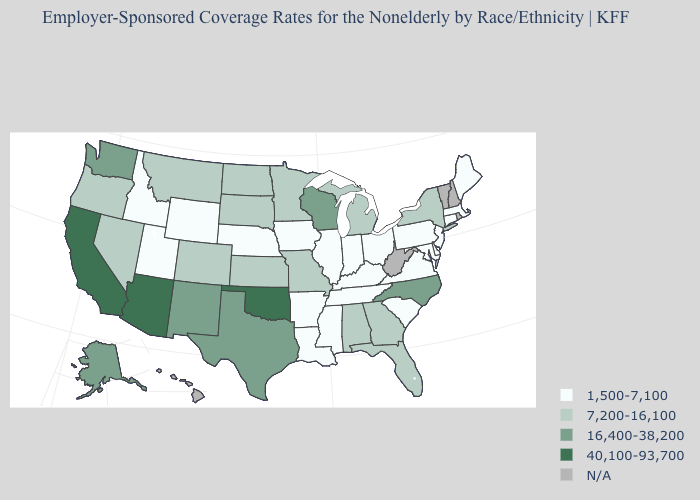Which states have the lowest value in the USA?
Write a very short answer. Arkansas, Connecticut, Delaware, Idaho, Illinois, Indiana, Iowa, Kentucky, Louisiana, Maine, Maryland, Massachusetts, Mississippi, Nebraska, New Jersey, Ohio, Pennsylvania, South Carolina, Tennessee, Utah, Virginia, Wyoming. What is the value of Oregon?
Short answer required. 7,200-16,100. What is the value of Iowa?
Short answer required. 1,500-7,100. Which states have the lowest value in the USA?
Be succinct. Arkansas, Connecticut, Delaware, Idaho, Illinois, Indiana, Iowa, Kentucky, Louisiana, Maine, Maryland, Massachusetts, Mississippi, Nebraska, New Jersey, Ohio, Pennsylvania, South Carolina, Tennessee, Utah, Virginia, Wyoming. Does Florida have the highest value in the South?
Be succinct. No. What is the value of California?
Be succinct. 40,100-93,700. Name the states that have a value in the range 7,200-16,100?
Concise answer only. Alabama, Colorado, Florida, Georgia, Kansas, Michigan, Minnesota, Missouri, Montana, Nevada, New York, North Dakota, Oregon, South Dakota. Name the states that have a value in the range 1,500-7,100?
Keep it brief. Arkansas, Connecticut, Delaware, Idaho, Illinois, Indiana, Iowa, Kentucky, Louisiana, Maine, Maryland, Massachusetts, Mississippi, Nebraska, New Jersey, Ohio, Pennsylvania, South Carolina, Tennessee, Utah, Virginia, Wyoming. What is the lowest value in the Northeast?
Short answer required. 1,500-7,100. Among the states that border Arizona , does New Mexico have the lowest value?
Short answer required. No. Among the states that border Oklahoma , does New Mexico have the highest value?
Concise answer only. Yes. Among the states that border Connecticut , which have the lowest value?
Be succinct. Massachusetts. Does Wyoming have the lowest value in the West?
Short answer required. Yes. Does the first symbol in the legend represent the smallest category?
Quick response, please. Yes. 